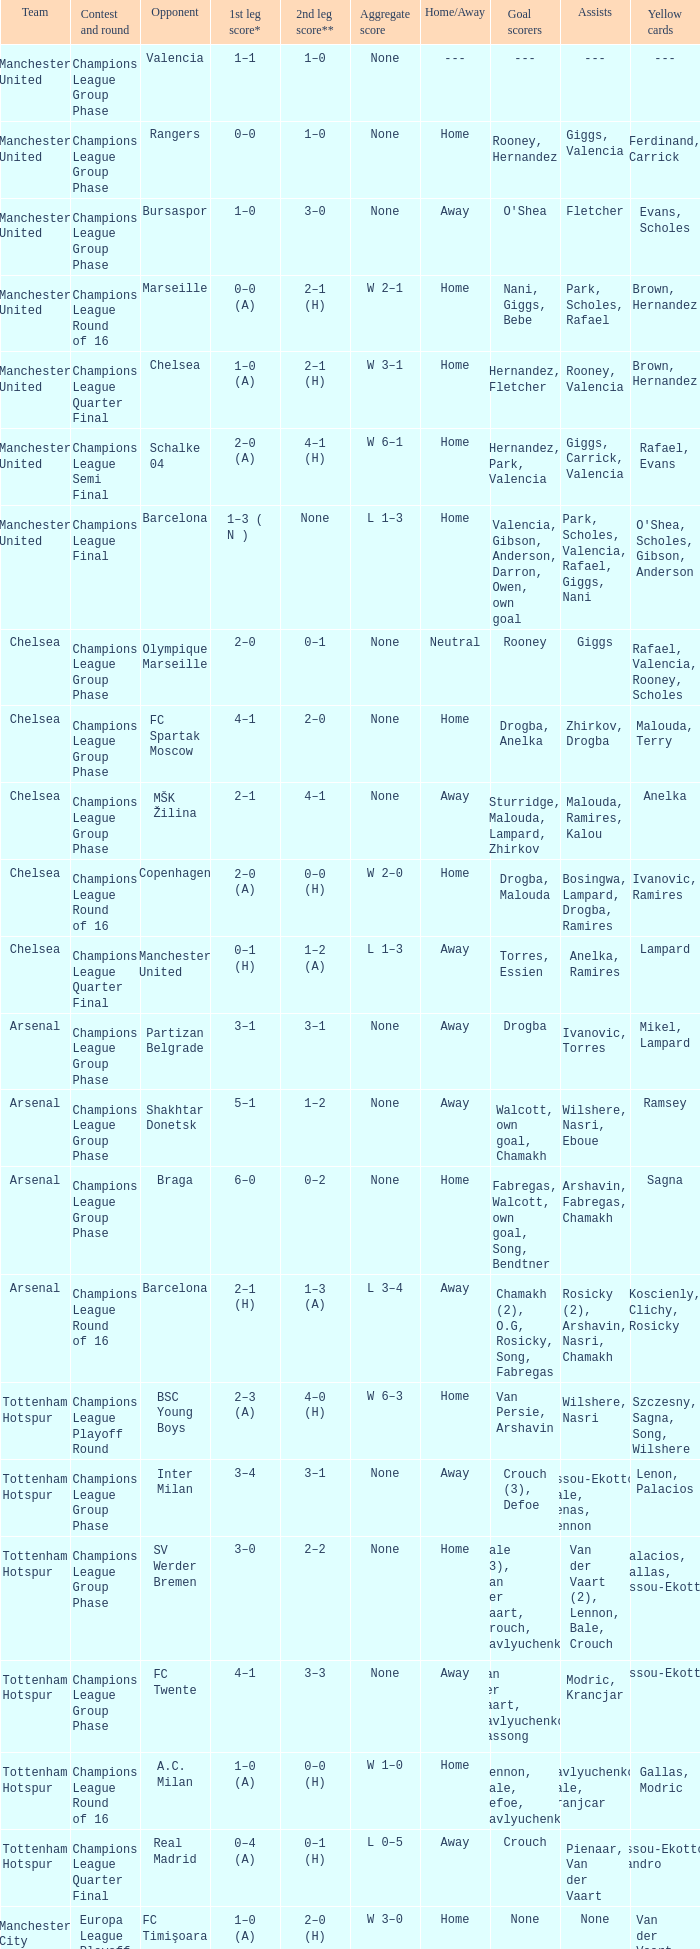How many goals did each one of the teams score in the first leg of the match between Liverpool and Trabzonspor? 1–0 (H). 